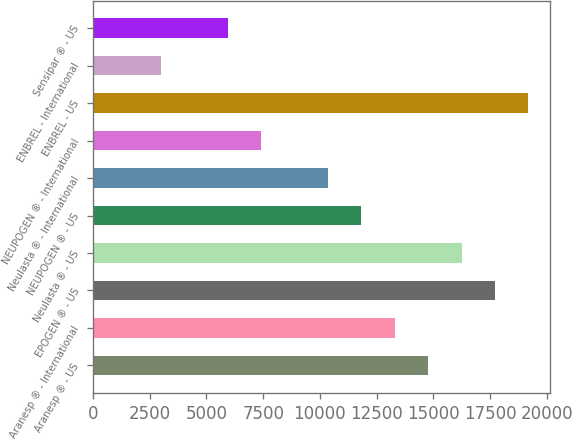<chart> <loc_0><loc_0><loc_500><loc_500><bar_chart><fcel>Aranesp ® - US<fcel>Aranesp ® - International<fcel>EPOGEN ® - US<fcel>Neulasta ® - US<fcel>NEUPOGEN ® - US<fcel>Neulasta ® - International<fcel>NEUPOGEN ® - International<fcel>ENBREL - US<fcel>ENBREL - International<fcel>Sensipar ® - US<nl><fcel>14771<fcel>13297.4<fcel>17718.2<fcel>16244.6<fcel>11823.8<fcel>10350.2<fcel>7403<fcel>19191.8<fcel>2982.2<fcel>5929.4<nl></chart> 